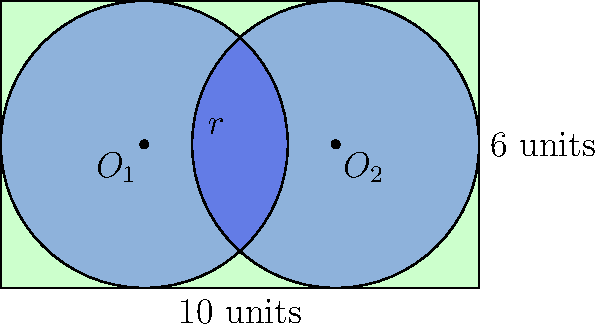A rectangular field measures 10 units in length and 6 units in width. Two circular irrigation systems with equal radii $r$ are to be installed in the field, as shown in the diagram. If the circles are tangent to each other and touch the sides of the field without overlapping, what is the maximum possible radius $r$ of each irrigation system? Let's approach this step-by-step:

1) Let the centers of the circles be $O_1$ and $O_2$. Due to symmetry, these centers will be located at $(3,3)$ and $(7,3)$ respectively.

2) The distance between the centers is equal to the width of the field minus twice the radius:
   $$10 - 2r = 4$$

3) This is because the circles are tangent to each other and to the sides of the field.

4) From this equation, we can derive:
   $$2r = 6$$
   $$r = 3$$

5) To verify, let's check if this radius satisfies the conditions for the height of the field:
   - The diameter of each circle (2r) is 6 units
   - This equals the height of the field

6) Therefore, the circles will exactly fit the height of the field.

Thus, the maximum possible radius that satisfies all conditions is 3 units.
Answer: $r = 3$ units 